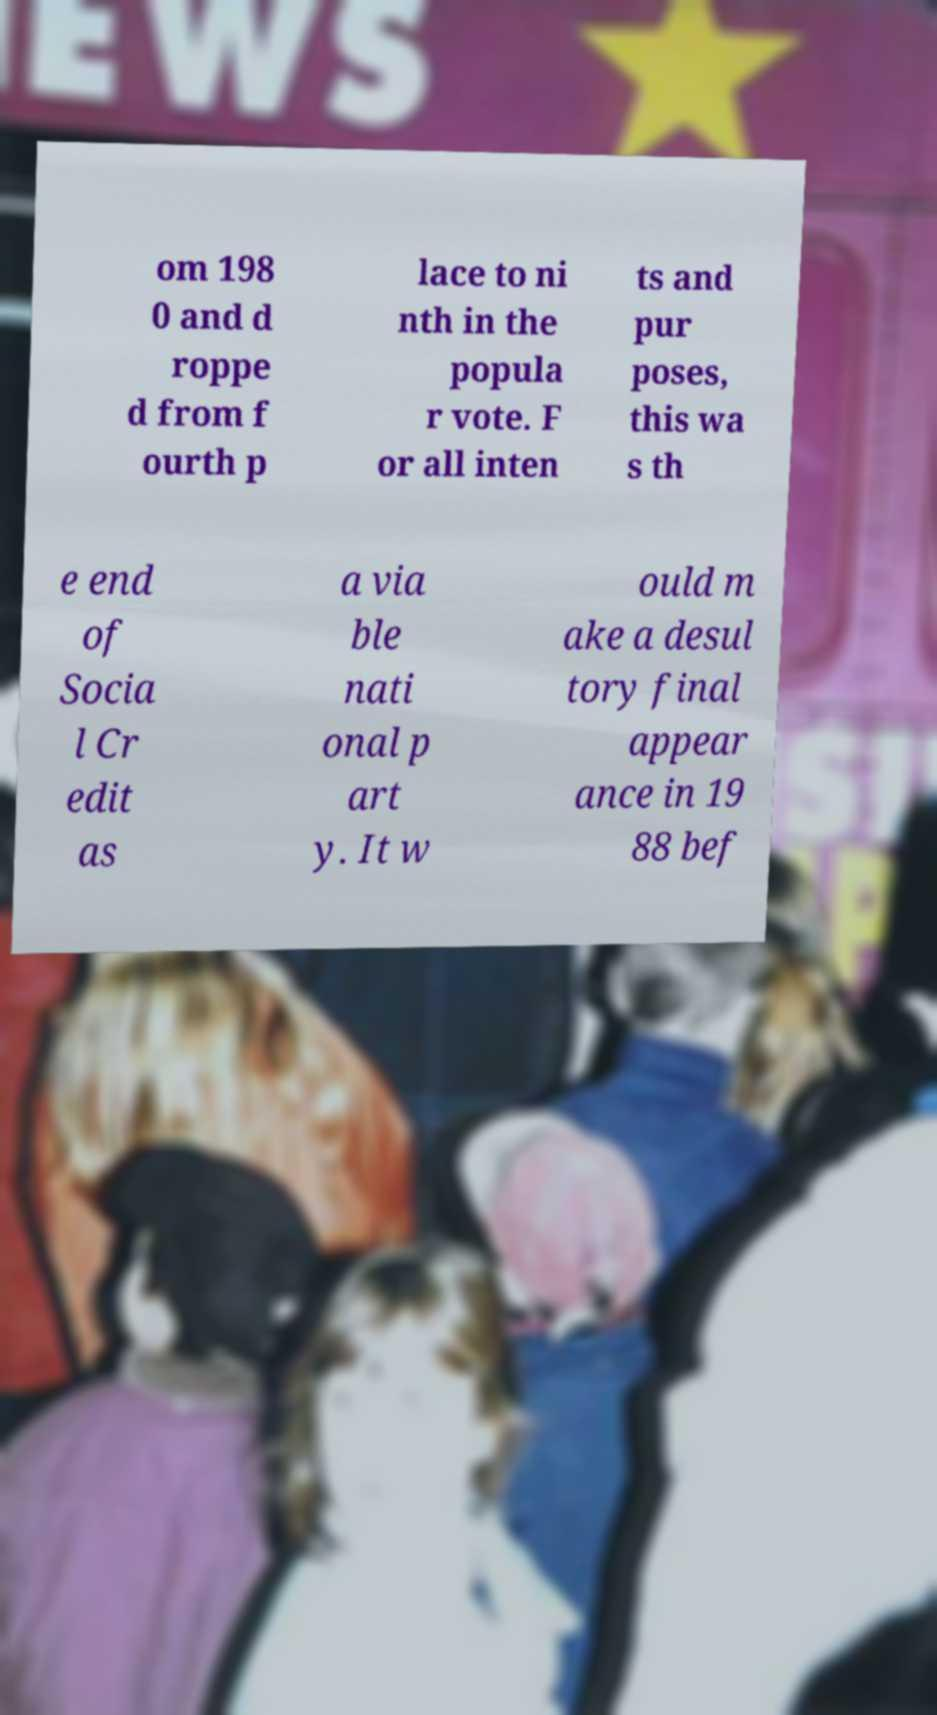Can you read and provide the text displayed in the image?This photo seems to have some interesting text. Can you extract and type it out for me? om 198 0 and d roppe d from f ourth p lace to ni nth in the popula r vote. F or all inten ts and pur poses, this wa s th e end of Socia l Cr edit as a via ble nati onal p art y. It w ould m ake a desul tory final appear ance in 19 88 bef 